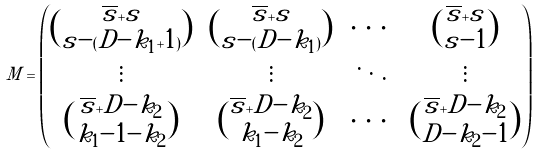<formula> <loc_0><loc_0><loc_500><loc_500>M = \begin{pmatrix} \binom { \overline { s } + s } { s - ( D - k _ { 1 } + 1 ) } & \binom { \overline { s } + s } { s - ( D - k _ { 1 } ) } & \cdots & \binom { \overline { s } + s } { s - 1 } \\ \vdots & \vdots & \ddots & \vdots \\ \binom { \overline { s } + D - k _ { 2 } } { k _ { 1 } - 1 - k _ { 2 } } & \binom { \overline { s } + D - k _ { 2 } } { k _ { 1 } - k _ { 2 } } & \cdots & \binom { \overline { s } + D - k _ { 2 } } { D - k _ { 2 } - 1 } \end{pmatrix}</formula> 